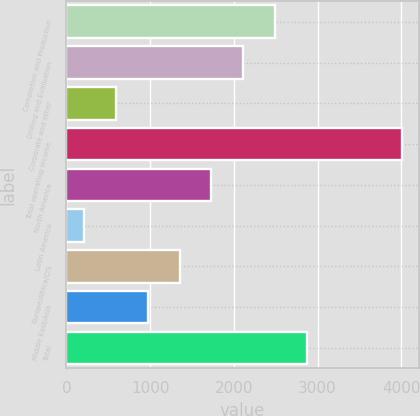<chart> <loc_0><loc_0><loc_500><loc_500><bar_chart><fcel>Completion and Production<fcel>Drilling and Evaluation<fcel>Corporate and other<fcel>Total operating income<fcel>North America<fcel>Latin America<fcel>Europe/Africa/CIS<fcel>Middle East/Asia<fcel>Total<nl><fcel>2491.6<fcel>2112<fcel>593.6<fcel>4010<fcel>1732.4<fcel>214<fcel>1352.8<fcel>973.2<fcel>2871.2<nl></chart> 